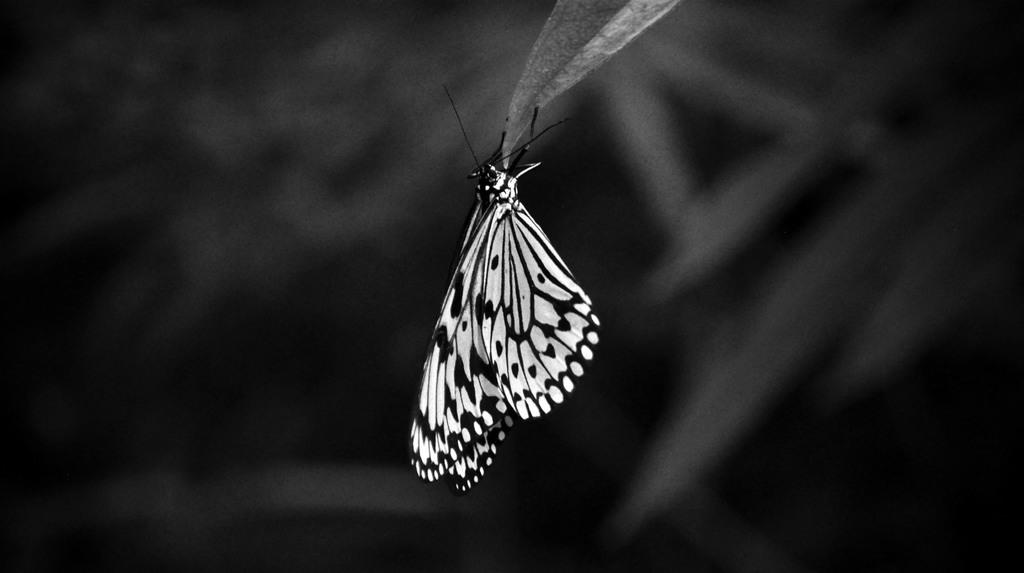What is the color scheme of the image? The image is black and white. What can be seen in the image? There is a butterfly in the image. Where is the butterfly located? The butterfly is present on a leaf. How would you describe the background of the image? The background of the image is blurry. What type of vest is the butterfly wearing in the image? There is no vest present in the image, as butterflies do not wear clothing. 